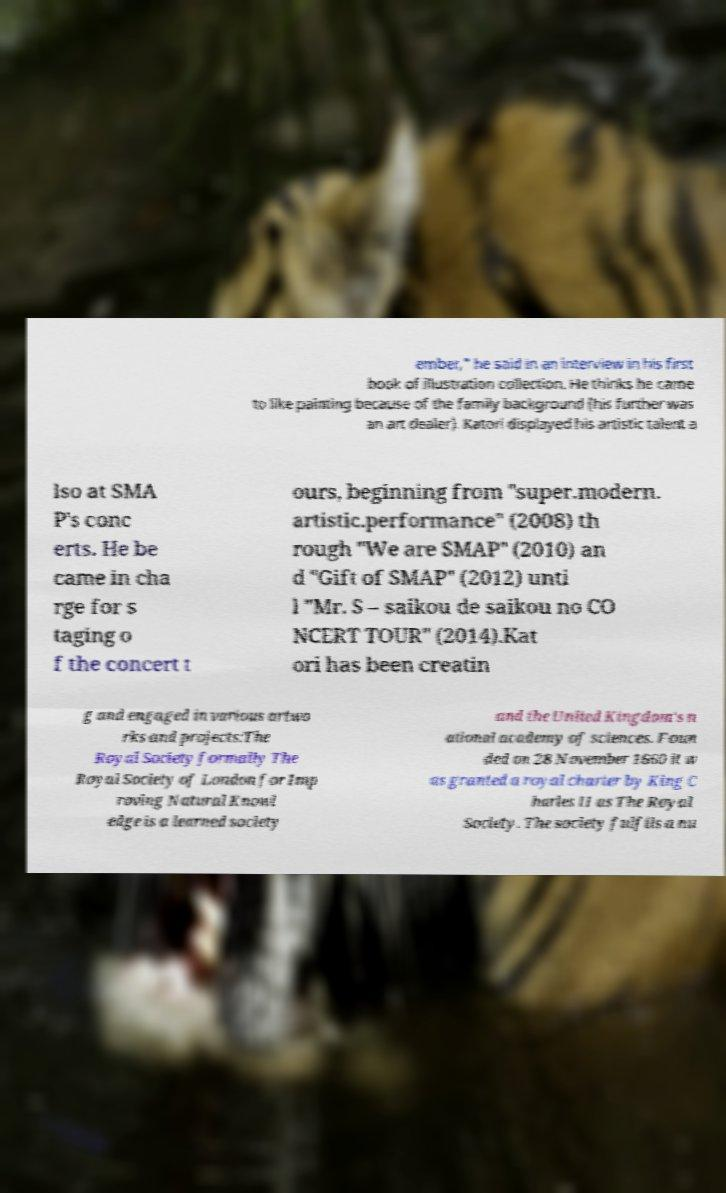There's text embedded in this image that I need extracted. Can you transcribe it verbatim? ember," he said in an interview in his first book of illustration collection. He thinks he came to like painting because of the family background (his further was an art dealer). Katori displayed his artistic talent a lso at SMA P's conc erts. He be came in cha rge for s taging o f the concert t ours, beginning from "super.modern. artistic.performance" (2008) th rough "We are SMAP" (2010) an d "Gift of SMAP" (2012) unti l "Mr. S – saikou de saikou no CO NCERT TOUR" (2014).Kat ori has been creatin g and engaged in various artwo rks and projects:The Royal Society formally The Royal Society of London for Imp roving Natural Knowl edge is a learned society and the United Kingdom's n ational academy of sciences. Foun ded on 28 November 1660 it w as granted a royal charter by King C harles II as The Royal Society. The society fulfils a nu 